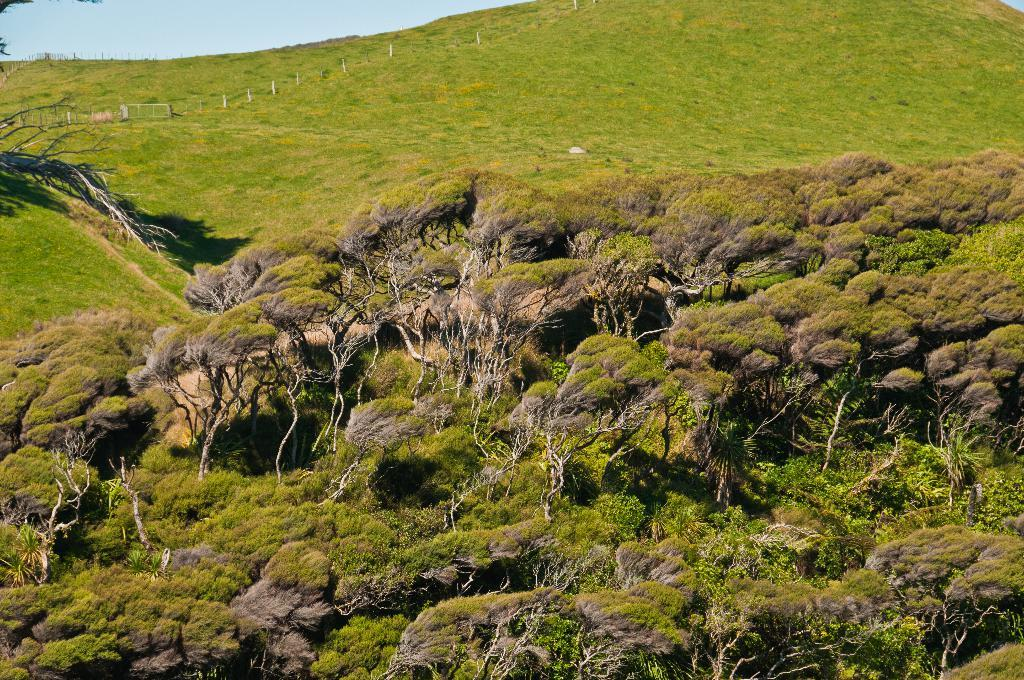What type of vegetation can be seen in the image? There are trees and grass in the image. What else is present in the image besides vegetation? There are poles in the image. What is visible at the top of the image? The sky is visible at the top of the image. Where are the trees located in the image? Trees are present at the bottom of the image. Can you see a lawyer wearing a veil in the image? There is no lawyer or veil present in the image. 